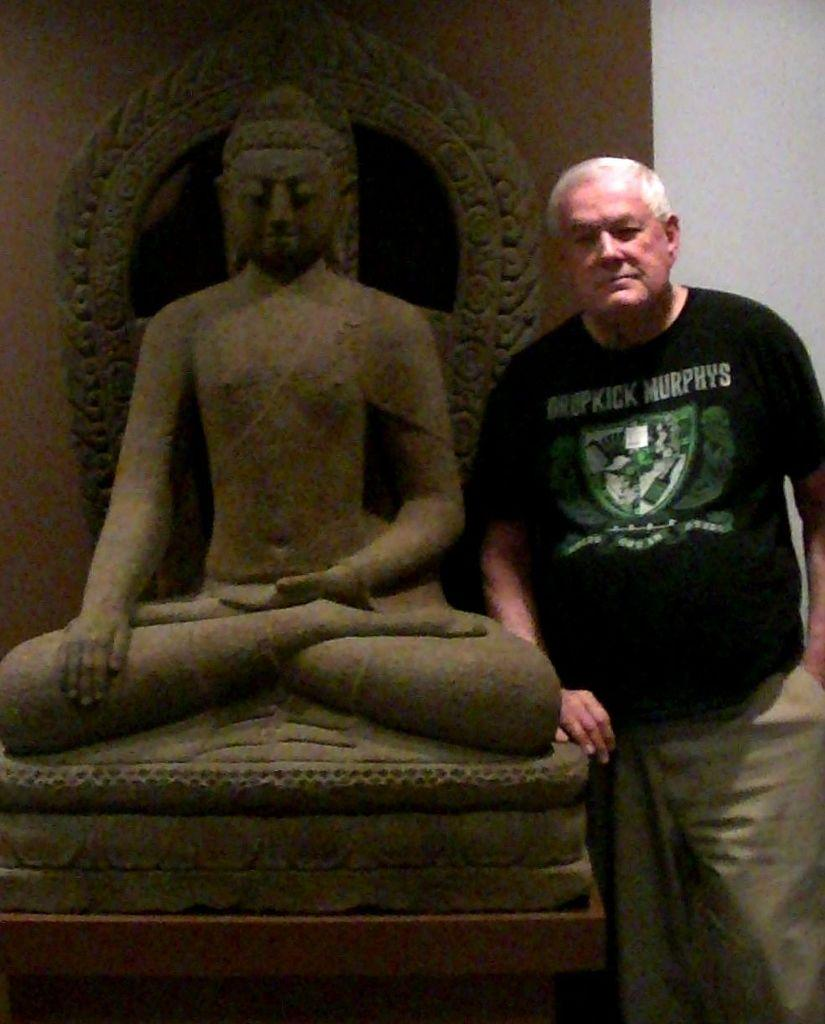Who is present in the image? There is a man in the image. What is the man doing in the image? The man is standing near a statue. What is the man wearing in the image? The man is wearing a black T-shirt. What type of apparatus is the man using to communicate with the statue in the image? There is no apparatus present in the image, and the man is not communicating with the statue. 